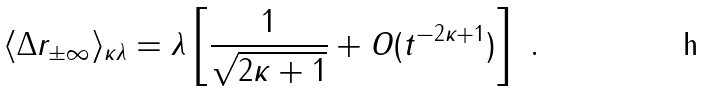Convert formula to latex. <formula><loc_0><loc_0><loc_500><loc_500>\langle \Delta r _ { \pm \infty } \rangle _ { \kappa \lambda } = \lambda \left [ \frac { 1 } { \sqrt { 2 \kappa + 1 } } + O ( t ^ { - 2 \kappa + 1 } ) \right ] \ .</formula> 